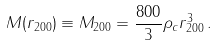Convert formula to latex. <formula><loc_0><loc_0><loc_500><loc_500>M ( r _ { 2 0 0 } ) \equiv M _ { 2 0 0 } = \frac { 8 0 0 } { 3 } \rho _ { c } r _ { 2 0 0 } ^ { 3 } \, .</formula> 